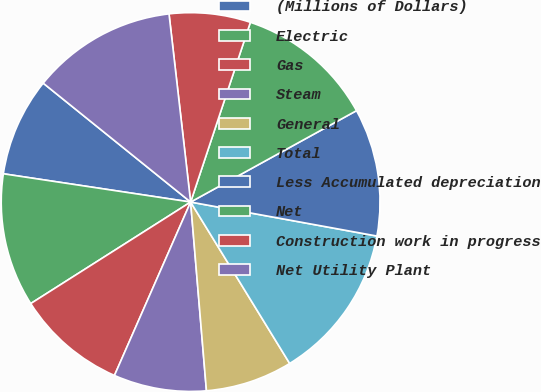Convert chart. <chart><loc_0><loc_0><loc_500><loc_500><pie_chart><fcel>(Millions of Dollars)<fcel>Electric<fcel>Gas<fcel>Steam<fcel>General<fcel>Total<fcel>Less Accumulated depreciation<fcel>Net<fcel>Construction work in progress<fcel>Net Utility Plant<nl><fcel>8.42%<fcel>11.39%<fcel>9.41%<fcel>7.92%<fcel>7.43%<fcel>13.37%<fcel>10.89%<fcel>11.88%<fcel>6.93%<fcel>12.38%<nl></chart> 